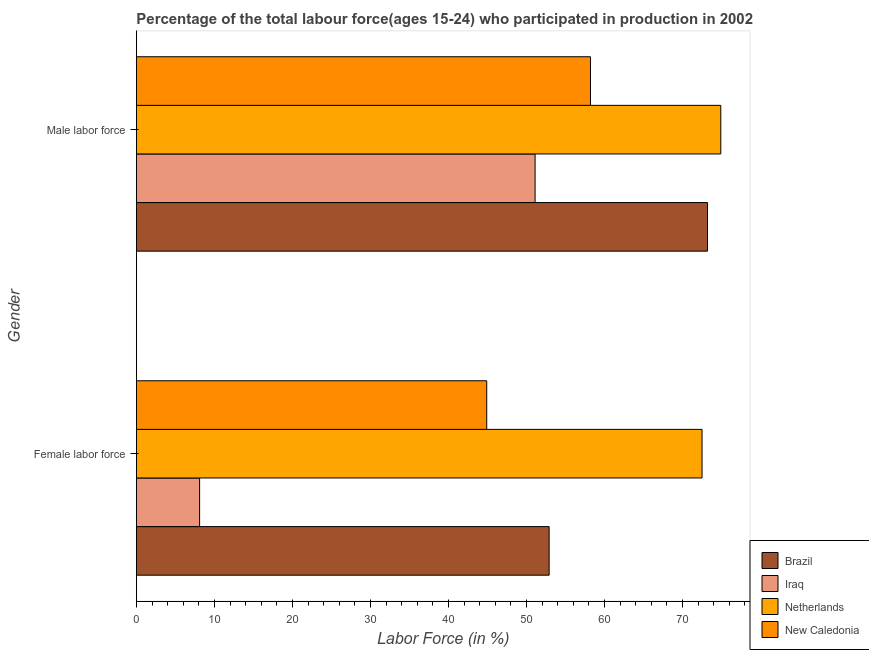Are the number of bars per tick equal to the number of legend labels?
Your answer should be very brief. Yes. Are the number of bars on each tick of the Y-axis equal?
Ensure brevity in your answer.  Yes. How many bars are there on the 1st tick from the top?
Keep it short and to the point. 4. What is the label of the 1st group of bars from the top?
Ensure brevity in your answer.  Male labor force. What is the percentage of female labor force in Brazil?
Your answer should be compact. 52.9. Across all countries, what is the maximum percentage of male labour force?
Make the answer very short. 74.9. Across all countries, what is the minimum percentage of male labour force?
Keep it short and to the point. 51.1. In which country was the percentage of male labour force maximum?
Your response must be concise. Netherlands. In which country was the percentage of female labor force minimum?
Make the answer very short. Iraq. What is the total percentage of male labour force in the graph?
Offer a very short reply. 257.4. What is the difference between the percentage of female labor force in Brazil and that in Netherlands?
Make the answer very short. -19.6. What is the difference between the percentage of male labour force in Iraq and the percentage of female labor force in New Caledonia?
Offer a very short reply. 6.2. What is the average percentage of male labour force per country?
Keep it short and to the point. 64.35. What is the difference between the percentage of female labor force and percentage of male labour force in Iraq?
Make the answer very short. -43. What is the ratio of the percentage of male labour force in Netherlands to that in New Caledonia?
Offer a very short reply. 1.29. Is the percentage of female labor force in Brazil less than that in Iraq?
Offer a very short reply. No. What does the 3rd bar from the top in Female labor force represents?
Provide a succinct answer. Iraq. What does the 1st bar from the bottom in Male labor force represents?
Provide a short and direct response. Brazil. Are all the bars in the graph horizontal?
Ensure brevity in your answer.  Yes. What is the difference between two consecutive major ticks on the X-axis?
Provide a short and direct response. 10. Are the values on the major ticks of X-axis written in scientific E-notation?
Keep it short and to the point. No. Where does the legend appear in the graph?
Ensure brevity in your answer.  Bottom right. How many legend labels are there?
Keep it short and to the point. 4. What is the title of the graph?
Keep it short and to the point. Percentage of the total labour force(ages 15-24) who participated in production in 2002. What is the label or title of the X-axis?
Ensure brevity in your answer.  Labor Force (in %). What is the Labor Force (in %) in Brazil in Female labor force?
Your response must be concise. 52.9. What is the Labor Force (in %) of Iraq in Female labor force?
Offer a terse response. 8.1. What is the Labor Force (in %) of Netherlands in Female labor force?
Provide a succinct answer. 72.5. What is the Labor Force (in %) of New Caledonia in Female labor force?
Your answer should be very brief. 44.9. What is the Labor Force (in %) in Brazil in Male labor force?
Make the answer very short. 73.2. What is the Labor Force (in %) of Iraq in Male labor force?
Your answer should be very brief. 51.1. What is the Labor Force (in %) of Netherlands in Male labor force?
Provide a short and direct response. 74.9. What is the Labor Force (in %) in New Caledonia in Male labor force?
Provide a short and direct response. 58.2. Across all Gender, what is the maximum Labor Force (in %) of Brazil?
Keep it short and to the point. 73.2. Across all Gender, what is the maximum Labor Force (in %) of Iraq?
Provide a short and direct response. 51.1. Across all Gender, what is the maximum Labor Force (in %) in Netherlands?
Offer a terse response. 74.9. Across all Gender, what is the maximum Labor Force (in %) in New Caledonia?
Your answer should be compact. 58.2. Across all Gender, what is the minimum Labor Force (in %) of Brazil?
Your response must be concise. 52.9. Across all Gender, what is the minimum Labor Force (in %) in Iraq?
Keep it short and to the point. 8.1. Across all Gender, what is the minimum Labor Force (in %) of Netherlands?
Ensure brevity in your answer.  72.5. Across all Gender, what is the minimum Labor Force (in %) of New Caledonia?
Ensure brevity in your answer.  44.9. What is the total Labor Force (in %) of Brazil in the graph?
Provide a succinct answer. 126.1. What is the total Labor Force (in %) in Iraq in the graph?
Offer a terse response. 59.2. What is the total Labor Force (in %) of Netherlands in the graph?
Your response must be concise. 147.4. What is the total Labor Force (in %) in New Caledonia in the graph?
Your answer should be very brief. 103.1. What is the difference between the Labor Force (in %) in Brazil in Female labor force and that in Male labor force?
Make the answer very short. -20.3. What is the difference between the Labor Force (in %) in Iraq in Female labor force and that in Male labor force?
Provide a short and direct response. -43. What is the difference between the Labor Force (in %) of Netherlands in Female labor force and that in Male labor force?
Offer a terse response. -2.4. What is the difference between the Labor Force (in %) in Brazil in Female labor force and the Labor Force (in %) in Iraq in Male labor force?
Your response must be concise. 1.8. What is the difference between the Labor Force (in %) of Brazil in Female labor force and the Labor Force (in %) of Netherlands in Male labor force?
Your response must be concise. -22. What is the difference between the Labor Force (in %) in Iraq in Female labor force and the Labor Force (in %) in Netherlands in Male labor force?
Offer a very short reply. -66.8. What is the difference between the Labor Force (in %) of Iraq in Female labor force and the Labor Force (in %) of New Caledonia in Male labor force?
Provide a succinct answer. -50.1. What is the average Labor Force (in %) in Brazil per Gender?
Keep it short and to the point. 63.05. What is the average Labor Force (in %) of Iraq per Gender?
Your answer should be very brief. 29.6. What is the average Labor Force (in %) in Netherlands per Gender?
Offer a very short reply. 73.7. What is the average Labor Force (in %) in New Caledonia per Gender?
Provide a short and direct response. 51.55. What is the difference between the Labor Force (in %) of Brazil and Labor Force (in %) of Iraq in Female labor force?
Offer a very short reply. 44.8. What is the difference between the Labor Force (in %) in Brazil and Labor Force (in %) in Netherlands in Female labor force?
Offer a terse response. -19.6. What is the difference between the Labor Force (in %) in Brazil and Labor Force (in %) in New Caledonia in Female labor force?
Make the answer very short. 8. What is the difference between the Labor Force (in %) of Iraq and Labor Force (in %) of Netherlands in Female labor force?
Your answer should be compact. -64.4. What is the difference between the Labor Force (in %) in Iraq and Labor Force (in %) in New Caledonia in Female labor force?
Provide a succinct answer. -36.8. What is the difference between the Labor Force (in %) of Netherlands and Labor Force (in %) of New Caledonia in Female labor force?
Your answer should be very brief. 27.6. What is the difference between the Labor Force (in %) in Brazil and Labor Force (in %) in Iraq in Male labor force?
Make the answer very short. 22.1. What is the difference between the Labor Force (in %) in Brazil and Labor Force (in %) in Netherlands in Male labor force?
Keep it short and to the point. -1.7. What is the difference between the Labor Force (in %) in Brazil and Labor Force (in %) in New Caledonia in Male labor force?
Provide a succinct answer. 15. What is the difference between the Labor Force (in %) of Iraq and Labor Force (in %) of Netherlands in Male labor force?
Your answer should be very brief. -23.8. What is the difference between the Labor Force (in %) in Iraq and Labor Force (in %) in New Caledonia in Male labor force?
Your answer should be very brief. -7.1. What is the ratio of the Labor Force (in %) of Brazil in Female labor force to that in Male labor force?
Give a very brief answer. 0.72. What is the ratio of the Labor Force (in %) of Iraq in Female labor force to that in Male labor force?
Offer a very short reply. 0.16. What is the ratio of the Labor Force (in %) in Netherlands in Female labor force to that in Male labor force?
Offer a terse response. 0.97. What is the ratio of the Labor Force (in %) of New Caledonia in Female labor force to that in Male labor force?
Ensure brevity in your answer.  0.77. What is the difference between the highest and the second highest Labor Force (in %) in Brazil?
Your answer should be very brief. 20.3. What is the difference between the highest and the second highest Labor Force (in %) of Netherlands?
Keep it short and to the point. 2.4. What is the difference between the highest and the lowest Labor Force (in %) of Brazil?
Offer a terse response. 20.3. 